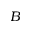Convert formula to latex. <formula><loc_0><loc_0><loc_500><loc_500>B</formula> 